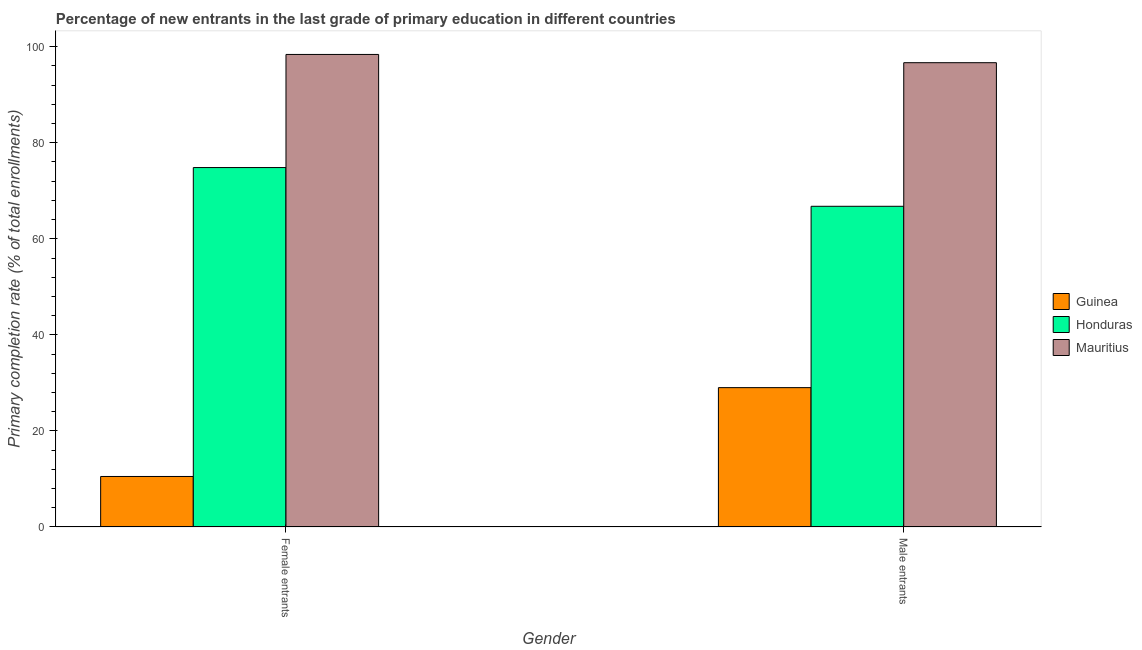What is the label of the 2nd group of bars from the left?
Your response must be concise. Male entrants. What is the primary completion rate of male entrants in Guinea?
Make the answer very short. 29.02. Across all countries, what is the maximum primary completion rate of female entrants?
Offer a very short reply. 98.39. Across all countries, what is the minimum primary completion rate of female entrants?
Keep it short and to the point. 10.52. In which country was the primary completion rate of male entrants maximum?
Offer a terse response. Mauritius. In which country was the primary completion rate of male entrants minimum?
Provide a succinct answer. Guinea. What is the total primary completion rate of female entrants in the graph?
Your answer should be compact. 183.74. What is the difference between the primary completion rate of male entrants in Mauritius and that in Honduras?
Your answer should be compact. 29.9. What is the difference between the primary completion rate of male entrants in Guinea and the primary completion rate of female entrants in Honduras?
Make the answer very short. -45.82. What is the average primary completion rate of female entrants per country?
Give a very brief answer. 61.25. What is the difference between the primary completion rate of male entrants and primary completion rate of female entrants in Honduras?
Give a very brief answer. -8.06. In how many countries, is the primary completion rate of male entrants greater than 12 %?
Your answer should be very brief. 3. What is the ratio of the primary completion rate of female entrants in Honduras to that in Guinea?
Offer a very short reply. 7.11. Is the primary completion rate of male entrants in Guinea less than that in Honduras?
Provide a succinct answer. Yes. What does the 3rd bar from the left in Female entrants represents?
Offer a terse response. Mauritius. What does the 1st bar from the right in Male entrants represents?
Make the answer very short. Mauritius. How many bars are there?
Your answer should be compact. 6. Are all the bars in the graph horizontal?
Provide a short and direct response. No. How many countries are there in the graph?
Give a very brief answer. 3. What is the difference between two consecutive major ticks on the Y-axis?
Your answer should be compact. 20. Does the graph contain any zero values?
Give a very brief answer. No. Does the graph contain grids?
Provide a succinct answer. No. Where does the legend appear in the graph?
Offer a very short reply. Center right. How are the legend labels stacked?
Your answer should be very brief. Vertical. What is the title of the graph?
Keep it short and to the point. Percentage of new entrants in the last grade of primary education in different countries. Does "Cote d'Ivoire" appear as one of the legend labels in the graph?
Ensure brevity in your answer.  No. What is the label or title of the Y-axis?
Make the answer very short. Primary completion rate (% of total enrollments). What is the Primary completion rate (% of total enrollments) in Guinea in Female entrants?
Your response must be concise. 10.52. What is the Primary completion rate (% of total enrollments) of Honduras in Female entrants?
Your answer should be compact. 74.84. What is the Primary completion rate (% of total enrollments) in Mauritius in Female entrants?
Offer a very short reply. 98.39. What is the Primary completion rate (% of total enrollments) in Guinea in Male entrants?
Offer a very short reply. 29.02. What is the Primary completion rate (% of total enrollments) in Honduras in Male entrants?
Offer a very short reply. 66.77. What is the Primary completion rate (% of total enrollments) in Mauritius in Male entrants?
Your response must be concise. 96.67. Across all Gender, what is the maximum Primary completion rate (% of total enrollments) in Guinea?
Provide a succinct answer. 29.02. Across all Gender, what is the maximum Primary completion rate (% of total enrollments) of Honduras?
Make the answer very short. 74.84. Across all Gender, what is the maximum Primary completion rate (% of total enrollments) in Mauritius?
Your answer should be compact. 98.39. Across all Gender, what is the minimum Primary completion rate (% of total enrollments) in Guinea?
Your response must be concise. 10.52. Across all Gender, what is the minimum Primary completion rate (% of total enrollments) in Honduras?
Provide a succinct answer. 66.77. Across all Gender, what is the minimum Primary completion rate (% of total enrollments) of Mauritius?
Offer a very short reply. 96.67. What is the total Primary completion rate (% of total enrollments) of Guinea in the graph?
Provide a succinct answer. 39.53. What is the total Primary completion rate (% of total enrollments) in Honduras in the graph?
Your response must be concise. 141.61. What is the total Primary completion rate (% of total enrollments) in Mauritius in the graph?
Ensure brevity in your answer.  195.05. What is the difference between the Primary completion rate (% of total enrollments) in Guinea in Female entrants and that in Male entrants?
Provide a short and direct response. -18.5. What is the difference between the Primary completion rate (% of total enrollments) in Honduras in Female entrants and that in Male entrants?
Keep it short and to the point. 8.06. What is the difference between the Primary completion rate (% of total enrollments) of Mauritius in Female entrants and that in Male entrants?
Keep it short and to the point. 1.72. What is the difference between the Primary completion rate (% of total enrollments) of Guinea in Female entrants and the Primary completion rate (% of total enrollments) of Honduras in Male entrants?
Offer a very short reply. -56.25. What is the difference between the Primary completion rate (% of total enrollments) in Guinea in Female entrants and the Primary completion rate (% of total enrollments) in Mauritius in Male entrants?
Provide a short and direct response. -86.15. What is the difference between the Primary completion rate (% of total enrollments) in Honduras in Female entrants and the Primary completion rate (% of total enrollments) in Mauritius in Male entrants?
Provide a short and direct response. -21.83. What is the average Primary completion rate (% of total enrollments) in Guinea per Gender?
Ensure brevity in your answer.  19.77. What is the average Primary completion rate (% of total enrollments) in Honduras per Gender?
Offer a terse response. 70.8. What is the average Primary completion rate (% of total enrollments) of Mauritius per Gender?
Offer a very short reply. 97.53. What is the difference between the Primary completion rate (% of total enrollments) in Guinea and Primary completion rate (% of total enrollments) in Honduras in Female entrants?
Keep it short and to the point. -64.32. What is the difference between the Primary completion rate (% of total enrollments) in Guinea and Primary completion rate (% of total enrollments) in Mauritius in Female entrants?
Ensure brevity in your answer.  -87.87. What is the difference between the Primary completion rate (% of total enrollments) of Honduras and Primary completion rate (% of total enrollments) of Mauritius in Female entrants?
Make the answer very short. -23.55. What is the difference between the Primary completion rate (% of total enrollments) of Guinea and Primary completion rate (% of total enrollments) of Honduras in Male entrants?
Provide a short and direct response. -37.76. What is the difference between the Primary completion rate (% of total enrollments) of Guinea and Primary completion rate (% of total enrollments) of Mauritius in Male entrants?
Provide a succinct answer. -67.65. What is the difference between the Primary completion rate (% of total enrollments) in Honduras and Primary completion rate (% of total enrollments) in Mauritius in Male entrants?
Keep it short and to the point. -29.9. What is the ratio of the Primary completion rate (% of total enrollments) of Guinea in Female entrants to that in Male entrants?
Make the answer very short. 0.36. What is the ratio of the Primary completion rate (% of total enrollments) in Honduras in Female entrants to that in Male entrants?
Your response must be concise. 1.12. What is the ratio of the Primary completion rate (% of total enrollments) of Mauritius in Female entrants to that in Male entrants?
Provide a short and direct response. 1.02. What is the difference between the highest and the second highest Primary completion rate (% of total enrollments) of Guinea?
Give a very brief answer. 18.5. What is the difference between the highest and the second highest Primary completion rate (% of total enrollments) of Honduras?
Keep it short and to the point. 8.06. What is the difference between the highest and the second highest Primary completion rate (% of total enrollments) of Mauritius?
Your answer should be compact. 1.72. What is the difference between the highest and the lowest Primary completion rate (% of total enrollments) of Guinea?
Make the answer very short. 18.5. What is the difference between the highest and the lowest Primary completion rate (% of total enrollments) of Honduras?
Your answer should be very brief. 8.06. What is the difference between the highest and the lowest Primary completion rate (% of total enrollments) in Mauritius?
Your response must be concise. 1.72. 